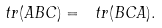<formula> <loc_0><loc_0><loc_500><loc_500>\ t r ( A B C ) = \ t r ( B C A ) .</formula> 